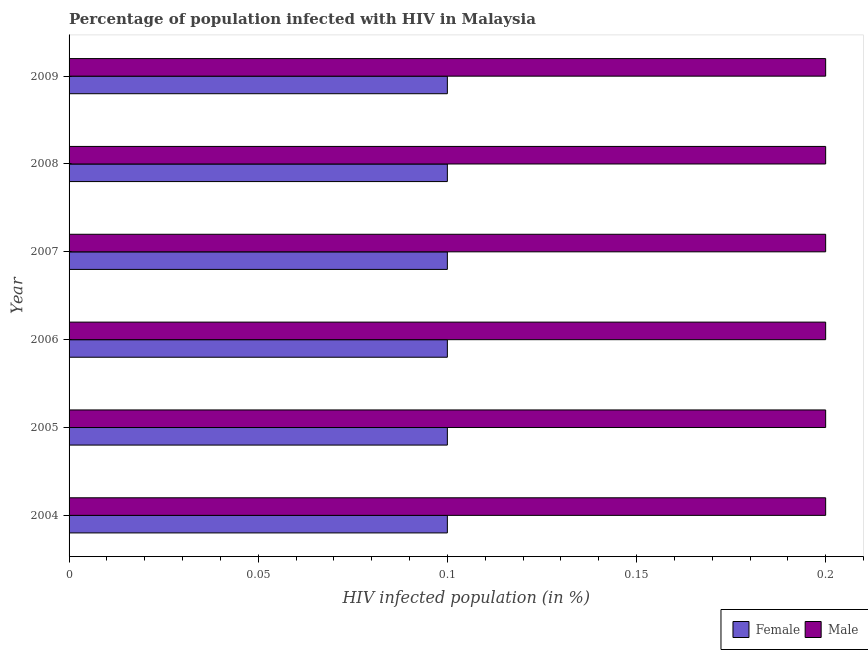How many different coloured bars are there?
Provide a succinct answer. 2. Are the number of bars per tick equal to the number of legend labels?
Your response must be concise. Yes. Are the number of bars on each tick of the Y-axis equal?
Give a very brief answer. Yes. How many bars are there on the 4th tick from the top?
Your response must be concise. 2. How many bars are there on the 6th tick from the bottom?
Give a very brief answer. 2. What is the label of the 3rd group of bars from the top?
Provide a short and direct response. 2007. In how many cases, is the number of bars for a given year not equal to the number of legend labels?
Provide a short and direct response. 0. What is the percentage of females who are infected with hiv in 2005?
Make the answer very short. 0.1. In which year was the percentage of females who are infected with hiv minimum?
Provide a succinct answer. 2004. What is the difference between the percentage of females who are infected with hiv in 2008 and that in 2009?
Ensure brevity in your answer.  0. What is the average percentage of females who are infected with hiv per year?
Keep it short and to the point. 0.1. Is the percentage of males who are infected with hiv in 2005 less than that in 2009?
Provide a succinct answer. No. Is the difference between the percentage of females who are infected with hiv in 2008 and 2009 greater than the difference between the percentage of males who are infected with hiv in 2008 and 2009?
Offer a very short reply. No. What is the difference between the highest and the second highest percentage of females who are infected with hiv?
Provide a succinct answer. 0. What is the difference between the highest and the lowest percentage of males who are infected with hiv?
Provide a short and direct response. 0. Is the sum of the percentage of males who are infected with hiv in 2005 and 2006 greater than the maximum percentage of females who are infected with hiv across all years?
Provide a short and direct response. Yes. How many bars are there?
Provide a short and direct response. 12. Are all the bars in the graph horizontal?
Provide a succinct answer. Yes. How many years are there in the graph?
Offer a terse response. 6. What is the difference between two consecutive major ticks on the X-axis?
Ensure brevity in your answer.  0.05. Are the values on the major ticks of X-axis written in scientific E-notation?
Offer a very short reply. No. Does the graph contain any zero values?
Your response must be concise. No. Does the graph contain grids?
Your answer should be very brief. No. What is the title of the graph?
Provide a short and direct response. Percentage of population infected with HIV in Malaysia. Does "ODA received" appear as one of the legend labels in the graph?
Offer a terse response. No. What is the label or title of the X-axis?
Provide a short and direct response. HIV infected population (in %). What is the HIV infected population (in %) of Male in 2004?
Ensure brevity in your answer.  0.2. What is the HIV infected population (in %) of Female in 2005?
Provide a short and direct response. 0.1. What is the HIV infected population (in %) of Female in 2006?
Offer a terse response. 0.1. What is the HIV infected population (in %) in Male in 2006?
Provide a succinct answer. 0.2. What is the HIV infected population (in %) in Female in 2008?
Make the answer very short. 0.1. Across all years, what is the maximum HIV infected population (in %) of Female?
Your answer should be very brief. 0.1. Across all years, what is the maximum HIV infected population (in %) in Male?
Offer a terse response. 0.2. Across all years, what is the minimum HIV infected population (in %) in Female?
Your answer should be very brief. 0.1. What is the total HIV infected population (in %) of Male in the graph?
Ensure brevity in your answer.  1.2. What is the difference between the HIV infected population (in %) of Male in 2004 and that in 2005?
Ensure brevity in your answer.  0. What is the difference between the HIV infected population (in %) in Female in 2004 and that in 2006?
Provide a short and direct response. 0. What is the difference between the HIV infected population (in %) in Female in 2004 and that in 2007?
Your response must be concise. 0. What is the difference between the HIV infected population (in %) of Female in 2004 and that in 2009?
Provide a succinct answer. 0. What is the difference between the HIV infected population (in %) in Male in 2004 and that in 2009?
Ensure brevity in your answer.  0. What is the difference between the HIV infected population (in %) in Male in 2005 and that in 2006?
Provide a succinct answer. 0. What is the difference between the HIV infected population (in %) of Female in 2005 and that in 2007?
Provide a succinct answer. 0. What is the difference between the HIV infected population (in %) of Male in 2005 and that in 2008?
Your answer should be compact. 0. What is the difference between the HIV infected population (in %) of Male in 2005 and that in 2009?
Your answer should be very brief. 0. What is the difference between the HIV infected population (in %) of Female in 2006 and that in 2007?
Offer a very short reply. 0. What is the difference between the HIV infected population (in %) of Male in 2006 and that in 2009?
Your answer should be very brief. 0. What is the difference between the HIV infected population (in %) in Male in 2007 and that in 2009?
Ensure brevity in your answer.  0. What is the difference between the HIV infected population (in %) of Female in 2004 and the HIV infected population (in %) of Male in 2005?
Ensure brevity in your answer.  -0.1. What is the difference between the HIV infected population (in %) of Female in 2004 and the HIV infected population (in %) of Male in 2007?
Keep it short and to the point. -0.1. What is the difference between the HIV infected population (in %) of Female in 2005 and the HIV infected population (in %) of Male in 2006?
Offer a terse response. -0.1. What is the difference between the HIV infected population (in %) in Female in 2005 and the HIV infected population (in %) in Male in 2007?
Make the answer very short. -0.1. What is the difference between the HIV infected population (in %) in Female in 2005 and the HIV infected population (in %) in Male in 2009?
Your answer should be compact. -0.1. What is the difference between the HIV infected population (in %) in Female in 2006 and the HIV infected population (in %) in Male in 2007?
Your answer should be compact. -0.1. What is the difference between the HIV infected population (in %) of Female in 2006 and the HIV infected population (in %) of Male in 2008?
Your answer should be very brief. -0.1. What is the difference between the HIV infected population (in %) in Female in 2007 and the HIV infected population (in %) in Male in 2008?
Keep it short and to the point. -0.1. What is the difference between the HIV infected population (in %) in Female in 2007 and the HIV infected population (in %) in Male in 2009?
Your answer should be very brief. -0.1. What is the difference between the HIV infected population (in %) in Female in 2008 and the HIV infected population (in %) in Male in 2009?
Provide a short and direct response. -0.1. What is the average HIV infected population (in %) of Female per year?
Provide a succinct answer. 0.1. What is the average HIV infected population (in %) in Male per year?
Provide a short and direct response. 0.2. In the year 2005, what is the difference between the HIV infected population (in %) in Female and HIV infected population (in %) in Male?
Offer a terse response. -0.1. In the year 2008, what is the difference between the HIV infected population (in %) of Female and HIV infected population (in %) of Male?
Your response must be concise. -0.1. What is the ratio of the HIV infected population (in %) in Female in 2004 to that in 2005?
Make the answer very short. 1. What is the ratio of the HIV infected population (in %) of Female in 2004 to that in 2008?
Offer a very short reply. 1. What is the ratio of the HIV infected population (in %) in Male in 2004 to that in 2008?
Offer a terse response. 1. What is the ratio of the HIV infected population (in %) of Male in 2004 to that in 2009?
Provide a short and direct response. 1. What is the ratio of the HIV infected population (in %) of Female in 2005 to that in 2006?
Your answer should be compact. 1. What is the ratio of the HIV infected population (in %) in Male in 2005 to that in 2006?
Offer a very short reply. 1. What is the ratio of the HIV infected population (in %) of Female in 2005 to that in 2007?
Your answer should be very brief. 1. What is the ratio of the HIV infected population (in %) in Male in 2005 to that in 2007?
Your answer should be very brief. 1. What is the ratio of the HIV infected population (in %) of Female in 2005 to that in 2008?
Ensure brevity in your answer.  1. What is the ratio of the HIV infected population (in %) of Male in 2005 to that in 2008?
Offer a terse response. 1. What is the ratio of the HIV infected population (in %) of Female in 2005 to that in 2009?
Keep it short and to the point. 1. What is the ratio of the HIV infected population (in %) in Male in 2006 to that in 2007?
Provide a succinct answer. 1. What is the ratio of the HIV infected population (in %) of Male in 2006 to that in 2008?
Offer a terse response. 1. What is the ratio of the HIV infected population (in %) of Female in 2006 to that in 2009?
Offer a very short reply. 1. What is the ratio of the HIV infected population (in %) in Female in 2007 to that in 2008?
Provide a short and direct response. 1. What is the ratio of the HIV infected population (in %) of Female in 2007 to that in 2009?
Make the answer very short. 1. What is the ratio of the HIV infected population (in %) of Male in 2007 to that in 2009?
Make the answer very short. 1. What is the difference between the highest and the lowest HIV infected population (in %) of Female?
Provide a succinct answer. 0. What is the difference between the highest and the lowest HIV infected population (in %) of Male?
Ensure brevity in your answer.  0. 